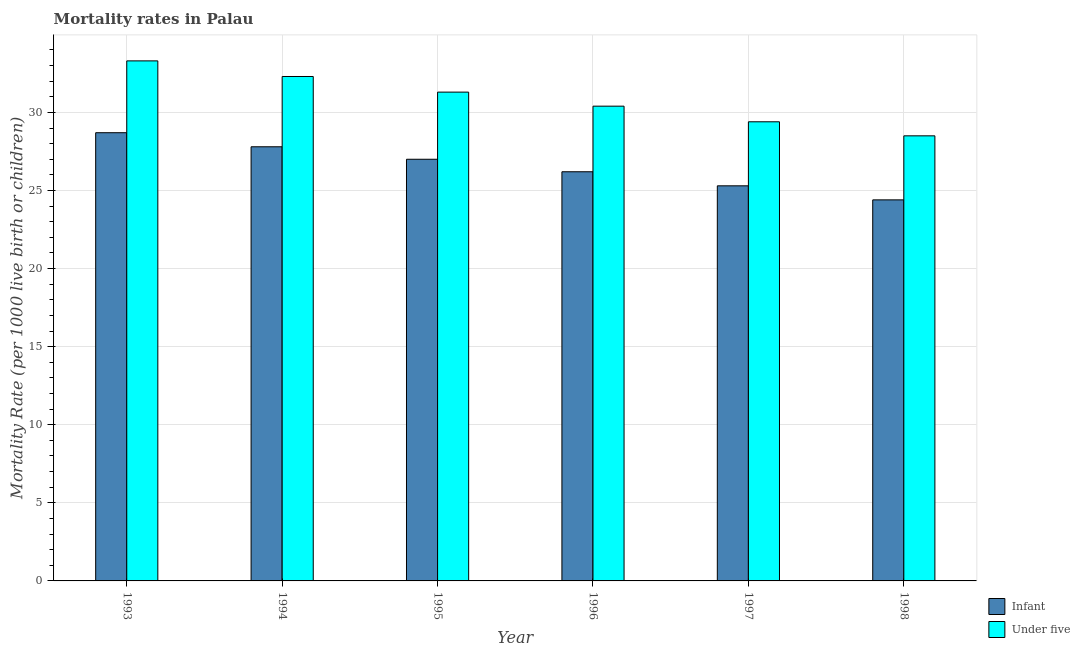How many different coloured bars are there?
Make the answer very short. 2. Are the number of bars per tick equal to the number of legend labels?
Keep it short and to the point. Yes. Are the number of bars on each tick of the X-axis equal?
Provide a short and direct response. Yes. How many bars are there on the 3rd tick from the left?
Your answer should be very brief. 2. How many bars are there on the 2nd tick from the right?
Your answer should be very brief. 2. In how many cases, is the number of bars for a given year not equal to the number of legend labels?
Ensure brevity in your answer.  0. What is the infant mortality rate in 1997?
Offer a very short reply. 25.3. Across all years, what is the maximum infant mortality rate?
Your answer should be compact. 28.7. Across all years, what is the minimum infant mortality rate?
Your answer should be compact. 24.4. In which year was the infant mortality rate maximum?
Your answer should be compact. 1993. In which year was the under-5 mortality rate minimum?
Ensure brevity in your answer.  1998. What is the total infant mortality rate in the graph?
Offer a very short reply. 159.4. What is the difference between the under-5 mortality rate in 1994 and that in 1995?
Offer a very short reply. 1. What is the difference between the under-5 mortality rate in 1994 and the infant mortality rate in 1998?
Your response must be concise. 3.8. What is the average under-5 mortality rate per year?
Ensure brevity in your answer.  30.87. In the year 1993, what is the difference between the infant mortality rate and under-5 mortality rate?
Your answer should be compact. 0. In how many years, is the under-5 mortality rate greater than 1?
Ensure brevity in your answer.  6. What is the ratio of the infant mortality rate in 1993 to that in 1996?
Provide a succinct answer. 1.1. What is the difference between the highest and the lowest infant mortality rate?
Your answer should be compact. 4.3. Is the sum of the under-5 mortality rate in 1994 and 1997 greater than the maximum infant mortality rate across all years?
Provide a succinct answer. Yes. What does the 2nd bar from the left in 1994 represents?
Keep it short and to the point. Under five. What does the 2nd bar from the right in 1997 represents?
Give a very brief answer. Infant. How many bars are there?
Your answer should be very brief. 12. How many years are there in the graph?
Provide a short and direct response. 6. What is the difference between two consecutive major ticks on the Y-axis?
Your answer should be compact. 5. Does the graph contain grids?
Your answer should be compact. Yes. Where does the legend appear in the graph?
Offer a very short reply. Bottom right. How are the legend labels stacked?
Offer a very short reply. Vertical. What is the title of the graph?
Offer a terse response. Mortality rates in Palau. Does "State government" appear as one of the legend labels in the graph?
Ensure brevity in your answer.  No. What is the label or title of the X-axis?
Offer a terse response. Year. What is the label or title of the Y-axis?
Ensure brevity in your answer.  Mortality Rate (per 1000 live birth or children). What is the Mortality Rate (per 1000 live birth or children) in Infant in 1993?
Give a very brief answer. 28.7. What is the Mortality Rate (per 1000 live birth or children) of Under five in 1993?
Your answer should be very brief. 33.3. What is the Mortality Rate (per 1000 live birth or children) of Infant in 1994?
Make the answer very short. 27.8. What is the Mortality Rate (per 1000 live birth or children) in Under five in 1994?
Offer a very short reply. 32.3. What is the Mortality Rate (per 1000 live birth or children) of Under five in 1995?
Keep it short and to the point. 31.3. What is the Mortality Rate (per 1000 live birth or children) in Infant in 1996?
Your answer should be compact. 26.2. What is the Mortality Rate (per 1000 live birth or children) in Under five in 1996?
Keep it short and to the point. 30.4. What is the Mortality Rate (per 1000 live birth or children) of Infant in 1997?
Keep it short and to the point. 25.3. What is the Mortality Rate (per 1000 live birth or children) of Under five in 1997?
Your answer should be compact. 29.4. What is the Mortality Rate (per 1000 live birth or children) of Infant in 1998?
Offer a terse response. 24.4. Across all years, what is the maximum Mortality Rate (per 1000 live birth or children) of Infant?
Keep it short and to the point. 28.7. Across all years, what is the maximum Mortality Rate (per 1000 live birth or children) of Under five?
Give a very brief answer. 33.3. Across all years, what is the minimum Mortality Rate (per 1000 live birth or children) of Infant?
Keep it short and to the point. 24.4. Across all years, what is the minimum Mortality Rate (per 1000 live birth or children) in Under five?
Your answer should be very brief. 28.5. What is the total Mortality Rate (per 1000 live birth or children) of Infant in the graph?
Provide a succinct answer. 159.4. What is the total Mortality Rate (per 1000 live birth or children) in Under five in the graph?
Offer a terse response. 185.2. What is the difference between the Mortality Rate (per 1000 live birth or children) of Under five in 1993 and that in 1994?
Your answer should be very brief. 1. What is the difference between the Mortality Rate (per 1000 live birth or children) of Under five in 1993 and that in 1996?
Provide a succinct answer. 2.9. What is the difference between the Mortality Rate (per 1000 live birth or children) in Infant in 1993 and that in 1998?
Offer a very short reply. 4.3. What is the difference between the Mortality Rate (per 1000 live birth or children) in Under five in 1994 and that in 1995?
Make the answer very short. 1. What is the difference between the Mortality Rate (per 1000 live birth or children) in Infant in 1994 and that in 1996?
Your answer should be compact. 1.6. What is the difference between the Mortality Rate (per 1000 live birth or children) in Under five in 1994 and that in 1997?
Your answer should be compact. 2.9. What is the difference between the Mortality Rate (per 1000 live birth or children) in Under five in 1994 and that in 1998?
Offer a very short reply. 3.8. What is the difference between the Mortality Rate (per 1000 live birth or children) of Infant in 1995 and that in 1996?
Offer a terse response. 0.8. What is the difference between the Mortality Rate (per 1000 live birth or children) in Under five in 1995 and that in 1996?
Your answer should be very brief. 0.9. What is the difference between the Mortality Rate (per 1000 live birth or children) in Under five in 1995 and that in 1997?
Offer a very short reply. 1.9. What is the difference between the Mortality Rate (per 1000 live birth or children) in Under five in 1996 and that in 1997?
Keep it short and to the point. 1. What is the difference between the Mortality Rate (per 1000 live birth or children) in Infant in 1996 and that in 1998?
Make the answer very short. 1.8. What is the difference between the Mortality Rate (per 1000 live birth or children) in Under five in 1996 and that in 1998?
Ensure brevity in your answer.  1.9. What is the difference between the Mortality Rate (per 1000 live birth or children) of Under five in 1997 and that in 1998?
Provide a succinct answer. 0.9. What is the difference between the Mortality Rate (per 1000 live birth or children) of Infant in 1993 and the Mortality Rate (per 1000 live birth or children) of Under five in 1994?
Keep it short and to the point. -3.6. What is the difference between the Mortality Rate (per 1000 live birth or children) in Infant in 1993 and the Mortality Rate (per 1000 live birth or children) in Under five in 1996?
Your answer should be very brief. -1.7. What is the difference between the Mortality Rate (per 1000 live birth or children) in Infant in 1994 and the Mortality Rate (per 1000 live birth or children) in Under five in 1995?
Your answer should be very brief. -3.5. What is the difference between the Mortality Rate (per 1000 live birth or children) of Infant in 1994 and the Mortality Rate (per 1000 live birth or children) of Under five in 1998?
Keep it short and to the point. -0.7. What is the difference between the Mortality Rate (per 1000 live birth or children) of Infant in 1995 and the Mortality Rate (per 1000 live birth or children) of Under five in 1996?
Ensure brevity in your answer.  -3.4. What is the difference between the Mortality Rate (per 1000 live birth or children) of Infant in 1996 and the Mortality Rate (per 1000 live birth or children) of Under five in 1997?
Offer a terse response. -3.2. What is the difference between the Mortality Rate (per 1000 live birth or children) of Infant in 1996 and the Mortality Rate (per 1000 live birth or children) of Under five in 1998?
Offer a terse response. -2.3. What is the average Mortality Rate (per 1000 live birth or children) in Infant per year?
Ensure brevity in your answer.  26.57. What is the average Mortality Rate (per 1000 live birth or children) in Under five per year?
Give a very brief answer. 30.87. In the year 1993, what is the difference between the Mortality Rate (per 1000 live birth or children) of Infant and Mortality Rate (per 1000 live birth or children) of Under five?
Offer a very short reply. -4.6. In the year 1996, what is the difference between the Mortality Rate (per 1000 live birth or children) of Infant and Mortality Rate (per 1000 live birth or children) of Under five?
Offer a very short reply. -4.2. In the year 1997, what is the difference between the Mortality Rate (per 1000 live birth or children) of Infant and Mortality Rate (per 1000 live birth or children) of Under five?
Your answer should be very brief. -4.1. What is the ratio of the Mortality Rate (per 1000 live birth or children) in Infant in 1993 to that in 1994?
Offer a very short reply. 1.03. What is the ratio of the Mortality Rate (per 1000 live birth or children) in Under five in 1993 to that in 1994?
Offer a terse response. 1.03. What is the ratio of the Mortality Rate (per 1000 live birth or children) in Infant in 1993 to that in 1995?
Your response must be concise. 1.06. What is the ratio of the Mortality Rate (per 1000 live birth or children) of Under five in 1993 to that in 1995?
Provide a succinct answer. 1.06. What is the ratio of the Mortality Rate (per 1000 live birth or children) of Infant in 1993 to that in 1996?
Keep it short and to the point. 1.1. What is the ratio of the Mortality Rate (per 1000 live birth or children) of Under five in 1993 to that in 1996?
Provide a short and direct response. 1.1. What is the ratio of the Mortality Rate (per 1000 live birth or children) of Infant in 1993 to that in 1997?
Give a very brief answer. 1.13. What is the ratio of the Mortality Rate (per 1000 live birth or children) in Under five in 1993 to that in 1997?
Provide a succinct answer. 1.13. What is the ratio of the Mortality Rate (per 1000 live birth or children) of Infant in 1993 to that in 1998?
Provide a succinct answer. 1.18. What is the ratio of the Mortality Rate (per 1000 live birth or children) of Under five in 1993 to that in 1998?
Keep it short and to the point. 1.17. What is the ratio of the Mortality Rate (per 1000 live birth or children) in Infant in 1994 to that in 1995?
Provide a succinct answer. 1.03. What is the ratio of the Mortality Rate (per 1000 live birth or children) in Under five in 1994 to that in 1995?
Your response must be concise. 1.03. What is the ratio of the Mortality Rate (per 1000 live birth or children) of Infant in 1994 to that in 1996?
Make the answer very short. 1.06. What is the ratio of the Mortality Rate (per 1000 live birth or children) in Under five in 1994 to that in 1996?
Your answer should be very brief. 1.06. What is the ratio of the Mortality Rate (per 1000 live birth or children) in Infant in 1994 to that in 1997?
Offer a terse response. 1.1. What is the ratio of the Mortality Rate (per 1000 live birth or children) in Under five in 1994 to that in 1997?
Your answer should be compact. 1.1. What is the ratio of the Mortality Rate (per 1000 live birth or children) in Infant in 1994 to that in 1998?
Your response must be concise. 1.14. What is the ratio of the Mortality Rate (per 1000 live birth or children) of Under five in 1994 to that in 1998?
Your answer should be compact. 1.13. What is the ratio of the Mortality Rate (per 1000 live birth or children) in Infant in 1995 to that in 1996?
Offer a terse response. 1.03. What is the ratio of the Mortality Rate (per 1000 live birth or children) in Under five in 1995 to that in 1996?
Offer a very short reply. 1.03. What is the ratio of the Mortality Rate (per 1000 live birth or children) in Infant in 1995 to that in 1997?
Give a very brief answer. 1.07. What is the ratio of the Mortality Rate (per 1000 live birth or children) in Under five in 1995 to that in 1997?
Your answer should be compact. 1.06. What is the ratio of the Mortality Rate (per 1000 live birth or children) in Infant in 1995 to that in 1998?
Ensure brevity in your answer.  1.11. What is the ratio of the Mortality Rate (per 1000 live birth or children) of Under five in 1995 to that in 1998?
Give a very brief answer. 1.1. What is the ratio of the Mortality Rate (per 1000 live birth or children) of Infant in 1996 to that in 1997?
Make the answer very short. 1.04. What is the ratio of the Mortality Rate (per 1000 live birth or children) in Under five in 1996 to that in 1997?
Provide a succinct answer. 1.03. What is the ratio of the Mortality Rate (per 1000 live birth or children) in Infant in 1996 to that in 1998?
Offer a very short reply. 1.07. What is the ratio of the Mortality Rate (per 1000 live birth or children) of Under five in 1996 to that in 1998?
Your answer should be compact. 1.07. What is the ratio of the Mortality Rate (per 1000 live birth or children) in Infant in 1997 to that in 1998?
Give a very brief answer. 1.04. What is the ratio of the Mortality Rate (per 1000 live birth or children) in Under five in 1997 to that in 1998?
Offer a very short reply. 1.03. What is the difference between the highest and the second highest Mortality Rate (per 1000 live birth or children) of Under five?
Provide a succinct answer. 1. What is the difference between the highest and the lowest Mortality Rate (per 1000 live birth or children) of Under five?
Make the answer very short. 4.8. 